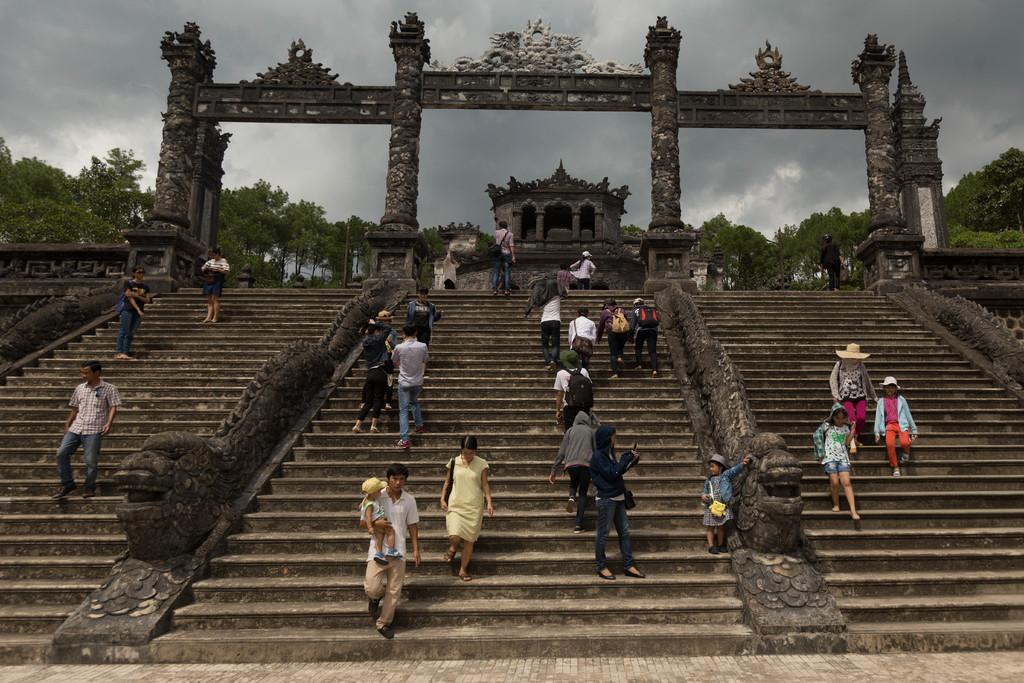What are the persons in the image doing? The persons in the image are climbing a staircase. What other objects or features can be seen in the image? There are sculptures, a building, entrance arches, trees, and the sky visible in the image. Can you describe the sky in the image? The sky is visible in the image, and clouds are visible in the sky. What type of boot can be seen on the fish in the image? There is no fish or boot present in the image. 